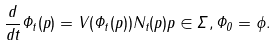<formula> <loc_0><loc_0><loc_500><loc_500>\frac { d } { d t } \Phi _ { t } ( p ) = V ( \Phi _ { t } ( p ) ) N _ { t } ( p ) p \in \Sigma , \Phi _ { 0 } = \phi .</formula> 